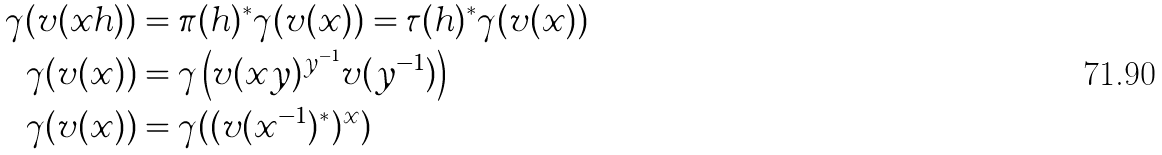<formula> <loc_0><loc_0><loc_500><loc_500>\gamma ( v ( x h ) ) & = \pi ( h ) ^ { \ast } \gamma ( v ( x ) ) = \tau ( h ) ^ { \ast } \gamma ( v ( x ) ) \\ \gamma ( v ( x ) ) & = \gamma \left ( v ( x y ) ^ { y ^ { - 1 } } v ( y ^ { - 1 } ) \right ) \\ \gamma ( v ( x ) ) & = \gamma ( ( v ( x ^ { - 1 } ) ^ { \ast } ) ^ { x } )</formula> 